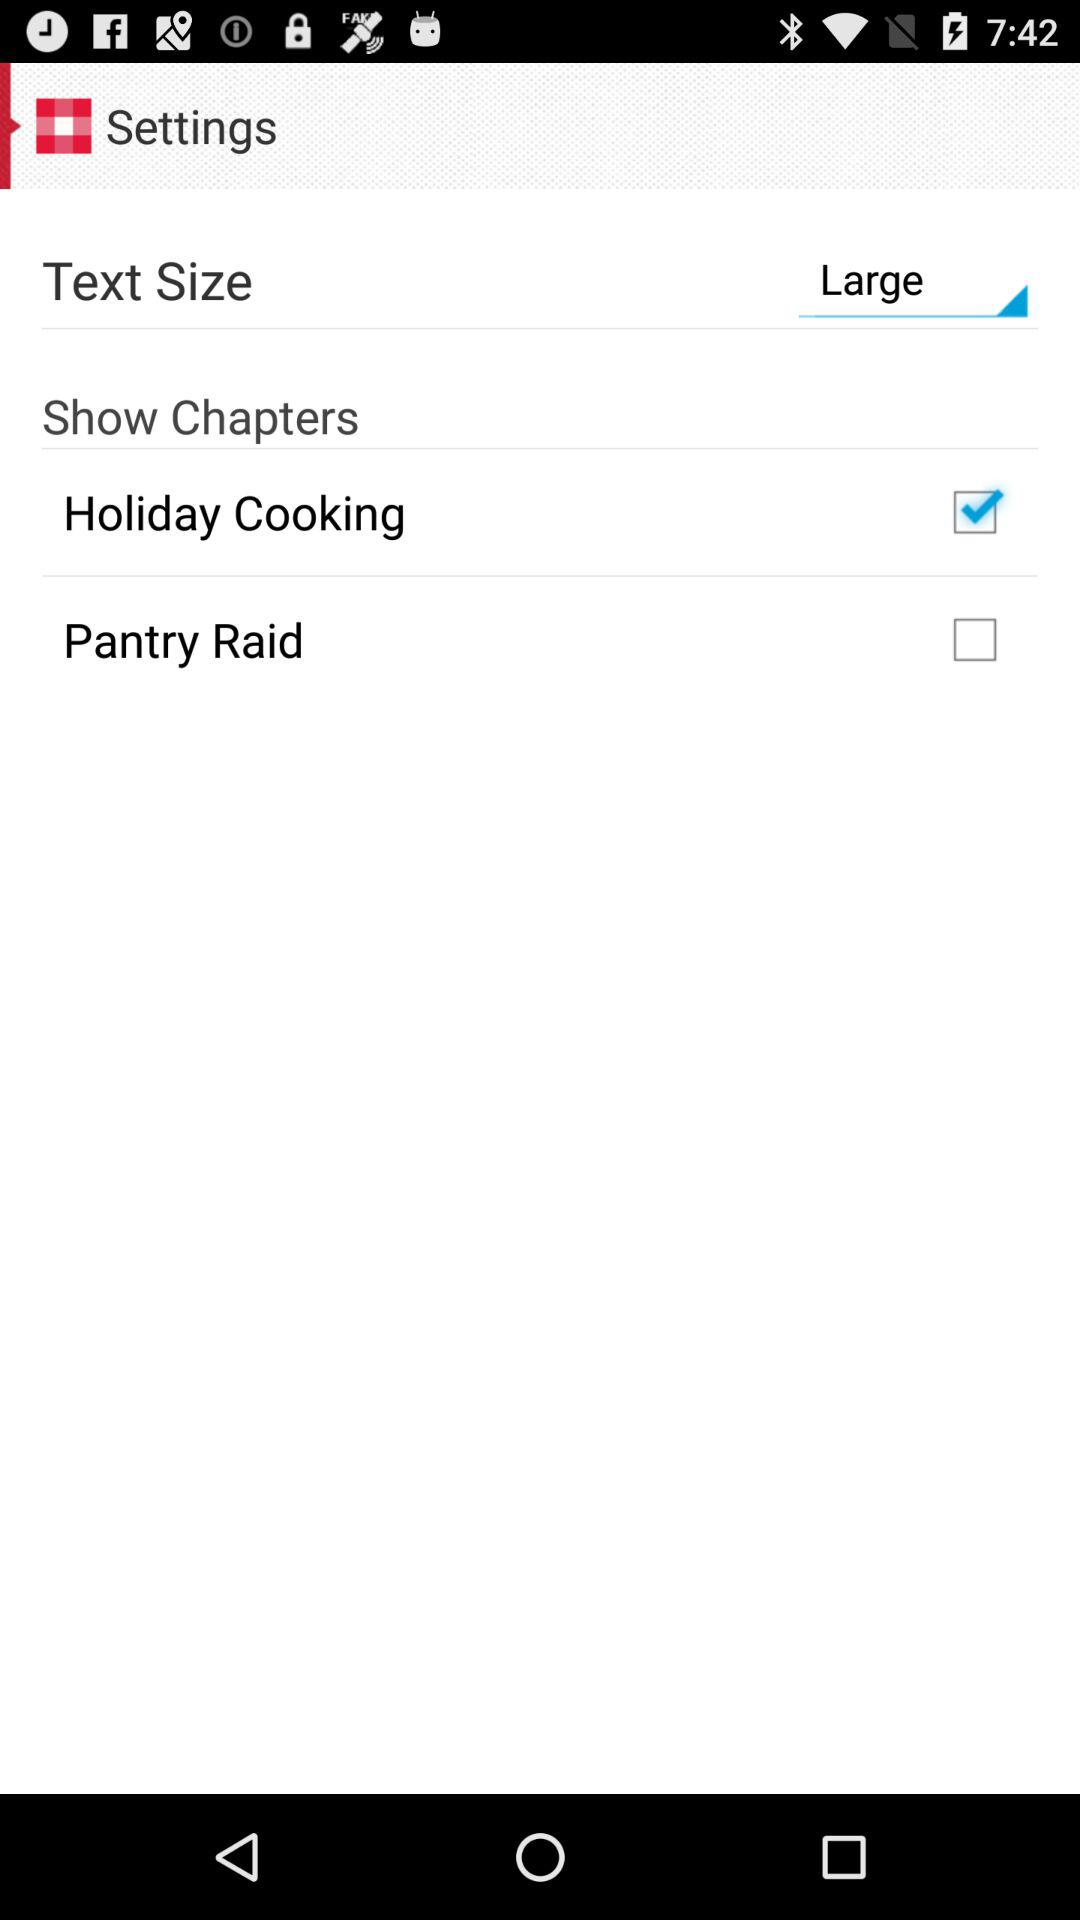Is "Show Chapters" selected or not selected?
When the provided information is insufficient, respond with <no answer>. <no answer> 